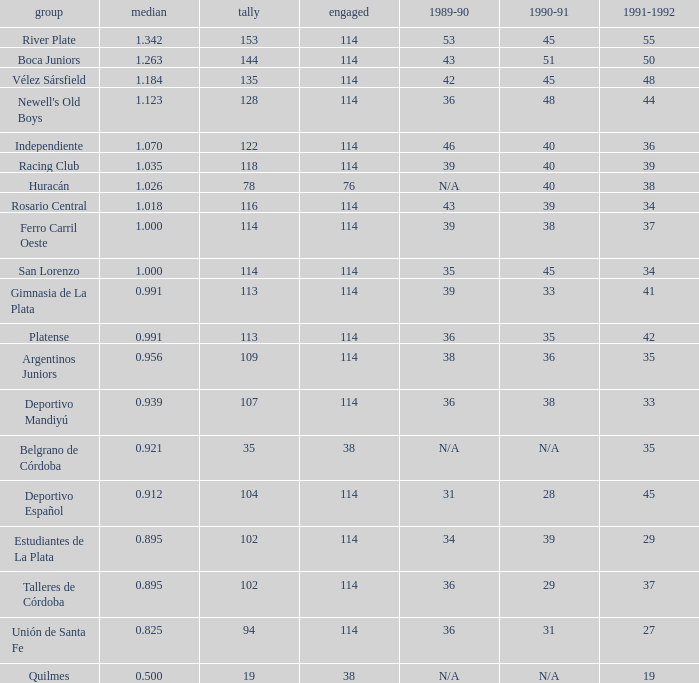How much Average has a 1989-90 of 36, and a Team of talleres de córdoba, and a Played smaller than 114? 0.0. Can you give me this table as a dict? {'header': ['group', 'median', 'tally', 'engaged', '1989-90', '1990-91', '1991-1992'], 'rows': [['River Plate', '1.342', '153', '114', '53', '45', '55'], ['Boca Juniors', '1.263', '144', '114', '43', '51', '50'], ['Vélez Sársfield', '1.184', '135', '114', '42', '45', '48'], ["Newell's Old Boys", '1.123', '128', '114', '36', '48', '44'], ['Independiente', '1.070', '122', '114', '46', '40', '36'], ['Racing Club', '1.035', '118', '114', '39', '40', '39'], ['Huracán', '1.026', '78', '76', 'N/A', '40', '38'], ['Rosario Central', '1.018', '116', '114', '43', '39', '34'], ['Ferro Carril Oeste', '1.000', '114', '114', '39', '38', '37'], ['San Lorenzo', '1.000', '114', '114', '35', '45', '34'], ['Gimnasia de La Plata', '0.991', '113', '114', '39', '33', '41'], ['Platense', '0.991', '113', '114', '36', '35', '42'], ['Argentinos Juniors', '0.956', '109', '114', '38', '36', '35'], ['Deportivo Mandiyú', '0.939', '107', '114', '36', '38', '33'], ['Belgrano de Córdoba', '0.921', '35', '38', 'N/A', 'N/A', '35'], ['Deportivo Español', '0.912', '104', '114', '31', '28', '45'], ['Estudiantes de La Plata', '0.895', '102', '114', '34', '39', '29'], ['Talleres de Córdoba', '0.895', '102', '114', '36', '29', '37'], ['Unión de Santa Fe', '0.825', '94', '114', '36', '31', '27'], ['Quilmes', '0.500', '19', '38', 'N/A', 'N/A', '19']]} 